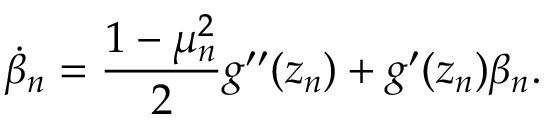Convert formula to latex. <formula><loc_0><loc_0><loc_500><loc_500>\dot { \beta } _ { n } = \frac { 1 - \mu _ { n } ^ { 2 } } { 2 } g ^ { \prime \prime } ( z _ { n } ) + g ^ { \prime } ( z _ { n } ) \beta _ { n } .</formula> 